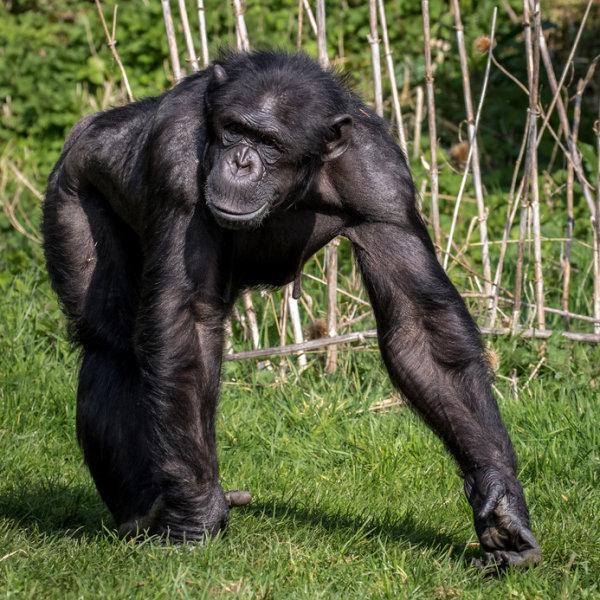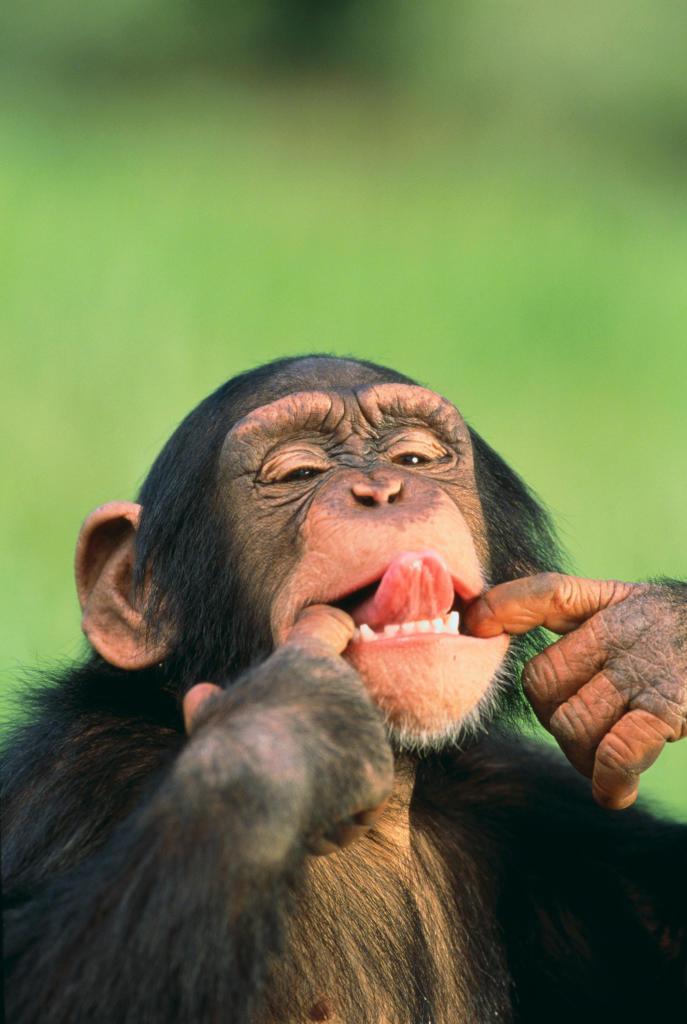The first image is the image on the left, the second image is the image on the right. Evaluate the accuracy of this statement regarding the images: "There are two apes". Is it true? Answer yes or no. Yes. 